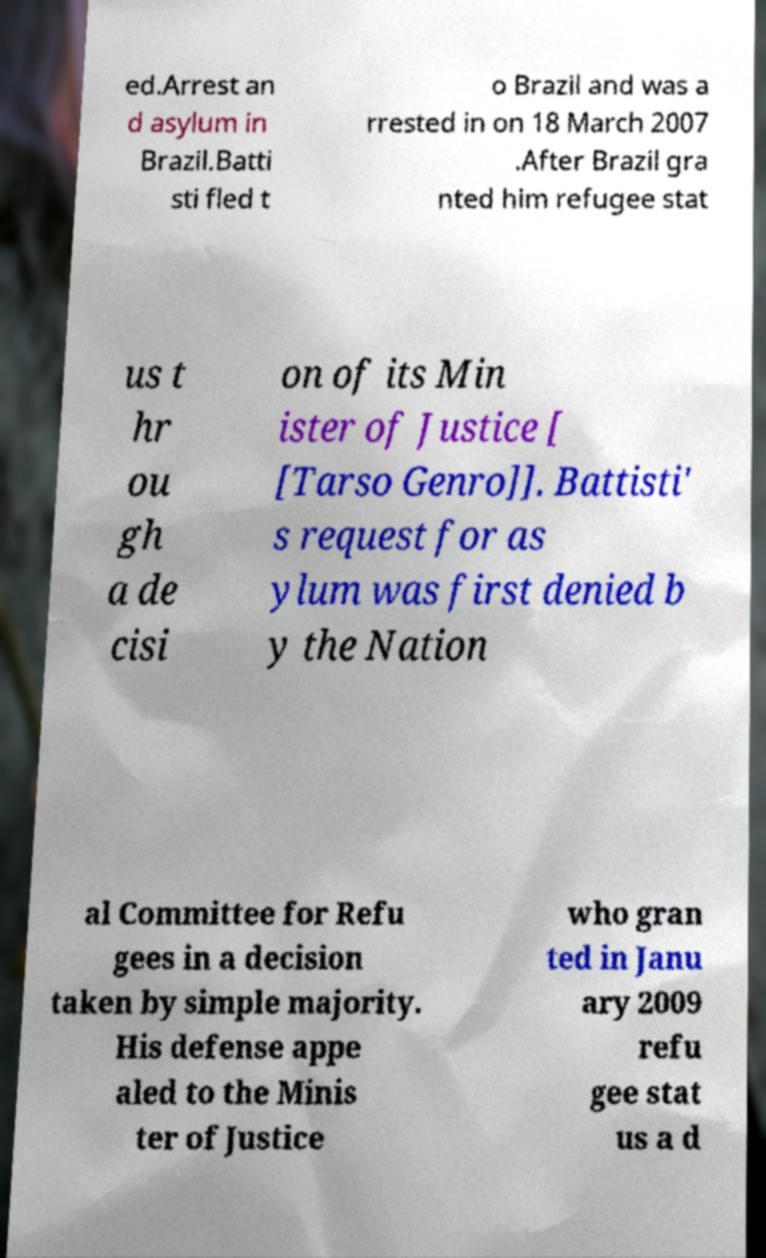There's text embedded in this image that I need extracted. Can you transcribe it verbatim? ed.Arrest an d asylum in Brazil.Batti sti fled t o Brazil and was a rrested in on 18 March 2007 .After Brazil gra nted him refugee stat us t hr ou gh a de cisi on of its Min ister of Justice [ [Tarso Genro]]. Battisti' s request for as ylum was first denied b y the Nation al Committee for Refu gees in a decision taken by simple majority. His defense appe aled to the Minis ter of Justice who gran ted in Janu ary 2009 refu gee stat us a d 